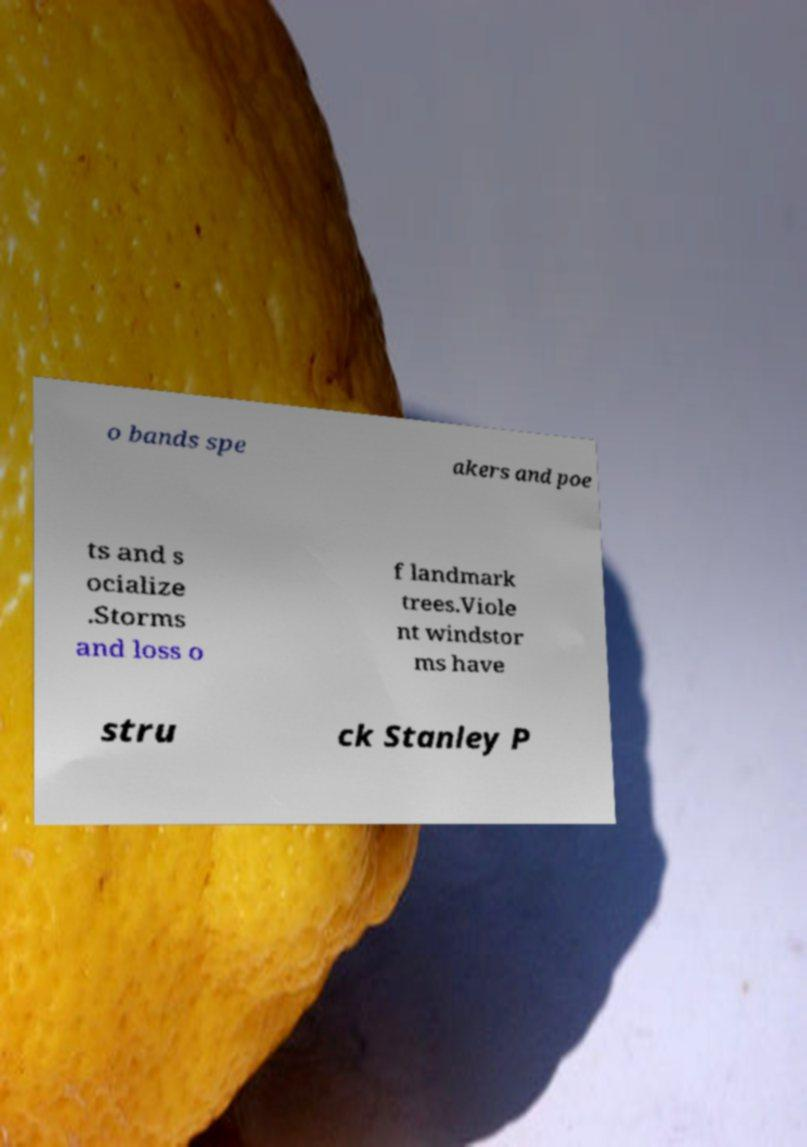What messages or text are displayed in this image? I need them in a readable, typed format. o bands spe akers and poe ts and s ocialize .Storms and loss o f landmark trees.Viole nt windstor ms have stru ck Stanley P 